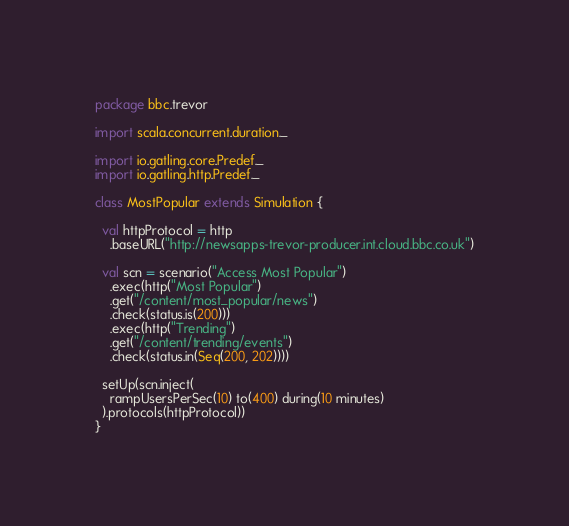Convert code to text. <code><loc_0><loc_0><loc_500><loc_500><_Scala_>package bbc.trevor

import scala.concurrent.duration._

import io.gatling.core.Predef._
import io.gatling.http.Predef._

class MostPopular extends Simulation {
   
  val httpProtocol = http
    .baseURL("http://newsapps-trevor-producer.int.cloud.bbc.co.uk")

  val scn = scenario("Access Most Popular")
    .exec(http("Most Popular")
    .get("/content/most_popular/news")
    .check(status.is(200)))
    .exec(http("Trending")
    .get("/content/trending/events")
    .check(status.in(Seq(200, 202)))) 

  setUp(scn.inject(
    rampUsersPerSec(10) to(400) during(10 minutes)
  ).protocols(httpProtocol))
}
</code> 